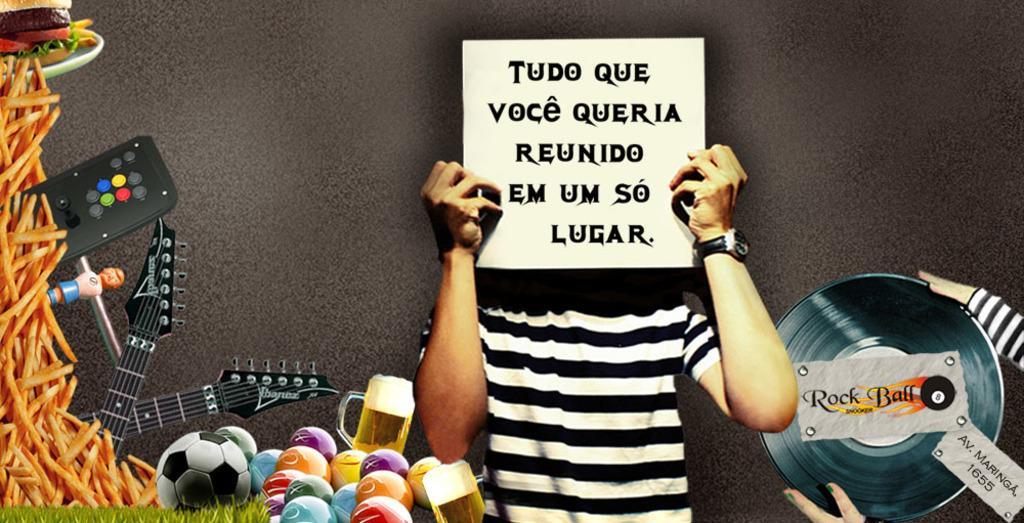Please provide a concise description of this image. This is an animated image. On the left side, there are balls, two guitars, a toy, a remote, grass and food items. On the right side, there is a person in a t-shirt, holding a poster and standing and there is a person holding a CD, on which there are two posters. And the background is gray in color. 